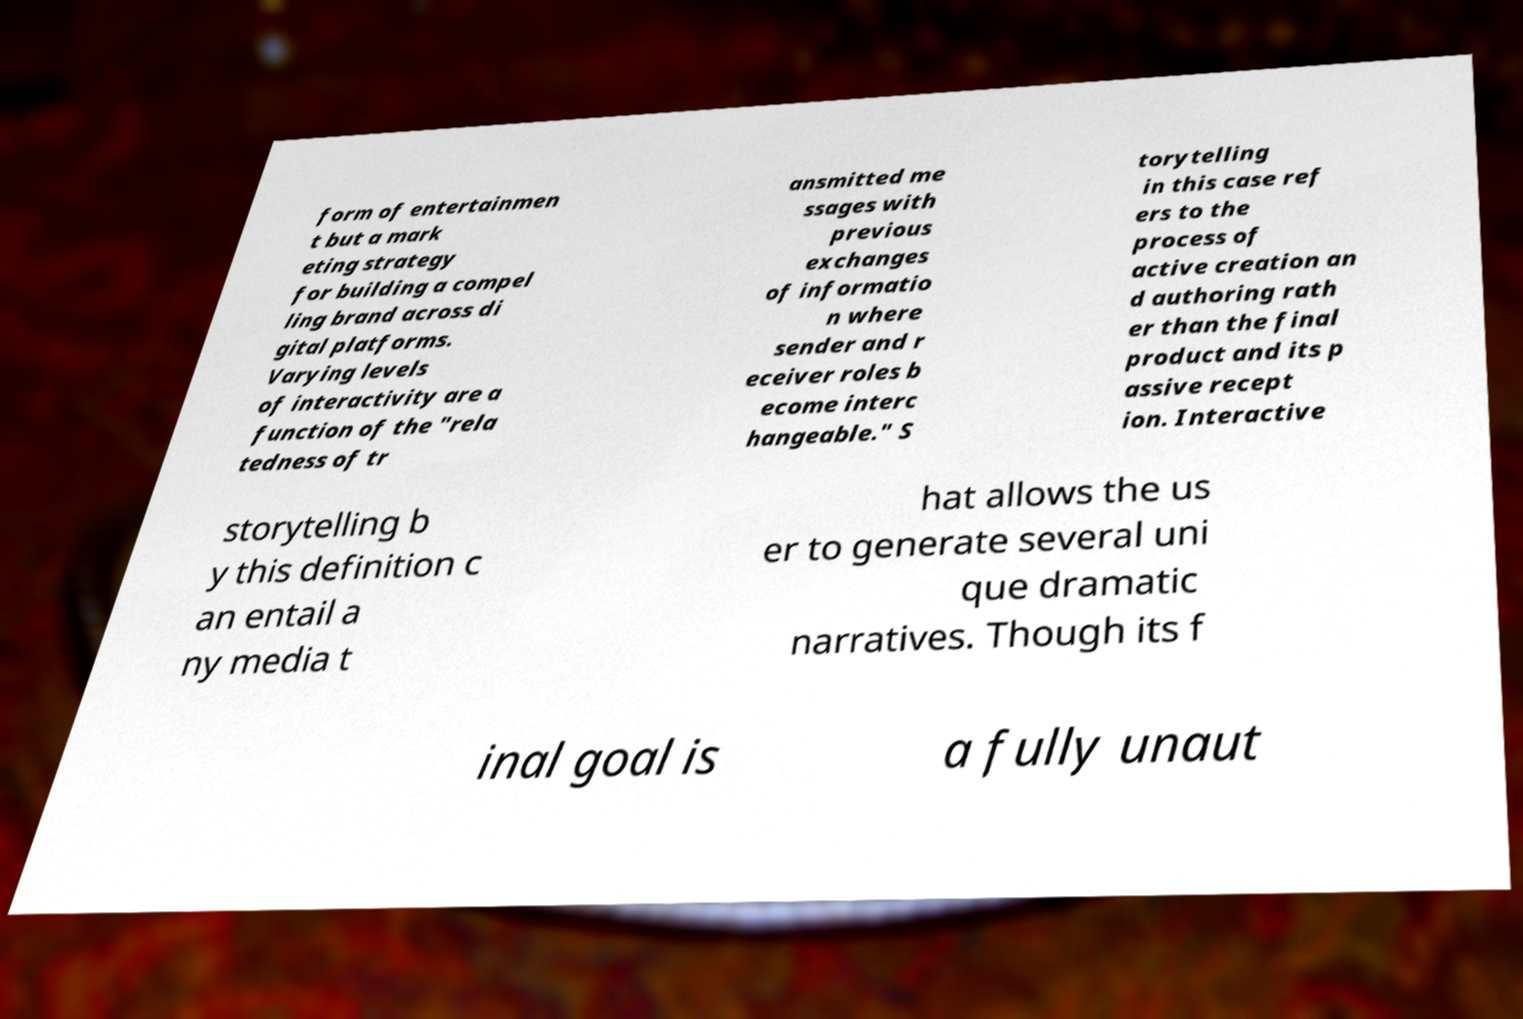Can you accurately transcribe the text from the provided image for me? form of entertainmen t but a mark eting strategy for building a compel ling brand across di gital platforms. Varying levels of interactivity are a function of the "rela tedness of tr ansmitted me ssages with previous exchanges of informatio n where sender and r eceiver roles b ecome interc hangeable." S torytelling in this case ref ers to the process of active creation an d authoring rath er than the final product and its p assive recept ion. Interactive storytelling b y this definition c an entail a ny media t hat allows the us er to generate several uni que dramatic narratives. Though its f inal goal is a fully unaut 